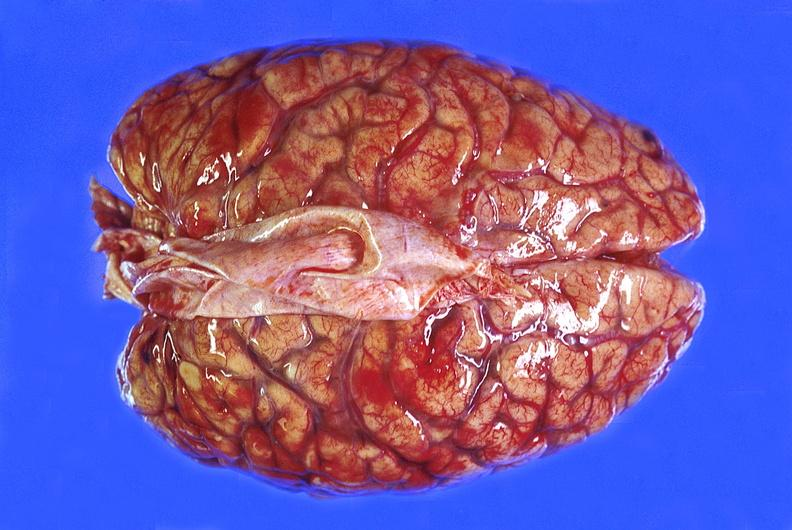s nervous present?
Answer the question using a single word or phrase. Yes 